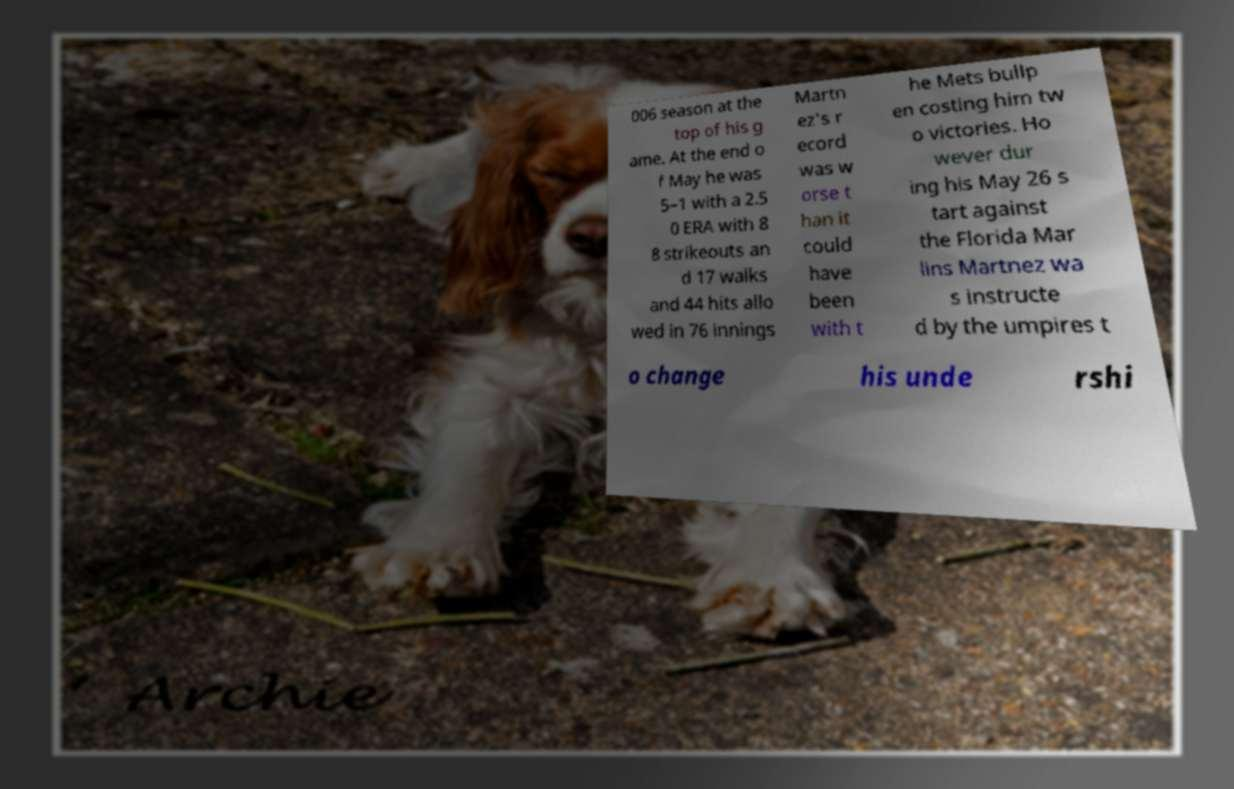For documentation purposes, I need the text within this image transcribed. Could you provide that? 006 season at the top of his g ame. At the end o f May he was 5–1 with a 2.5 0 ERA with 8 8 strikeouts an d 17 walks and 44 hits allo wed in 76 innings Martn ez's r ecord was w orse t han it could have been with t he Mets bullp en costing him tw o victories. Ho wever dur ing his May 26 s tart against the Florida Mar lins Martnez wa s instructe d by the umpires t o change his unde rshi 